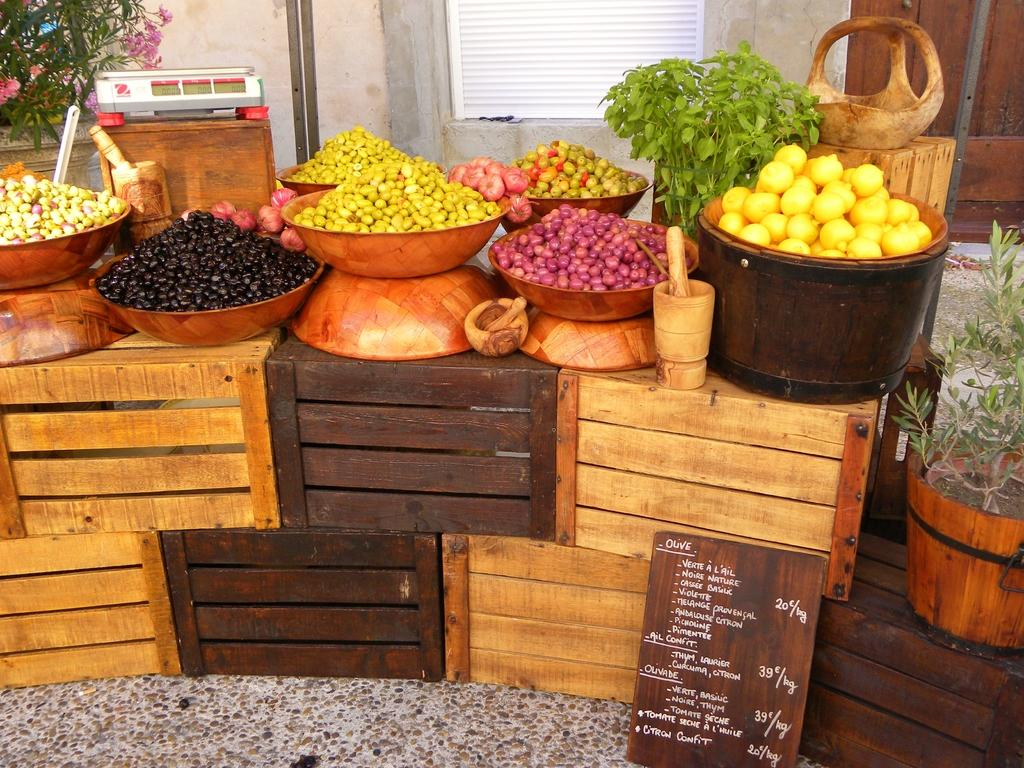What type of containers are present in the image? Objects are kept in containers in the image. Can you describe the material of the containers? There are wooden boxes in the image. What can be seen in the background of the image? There is a window and a wall in the background of the image. How many attempts were made to blow the wooden boxes in the image? There is no indication in the image that anyone attempted to blow the wooden boxes, as they are stationary containers. 